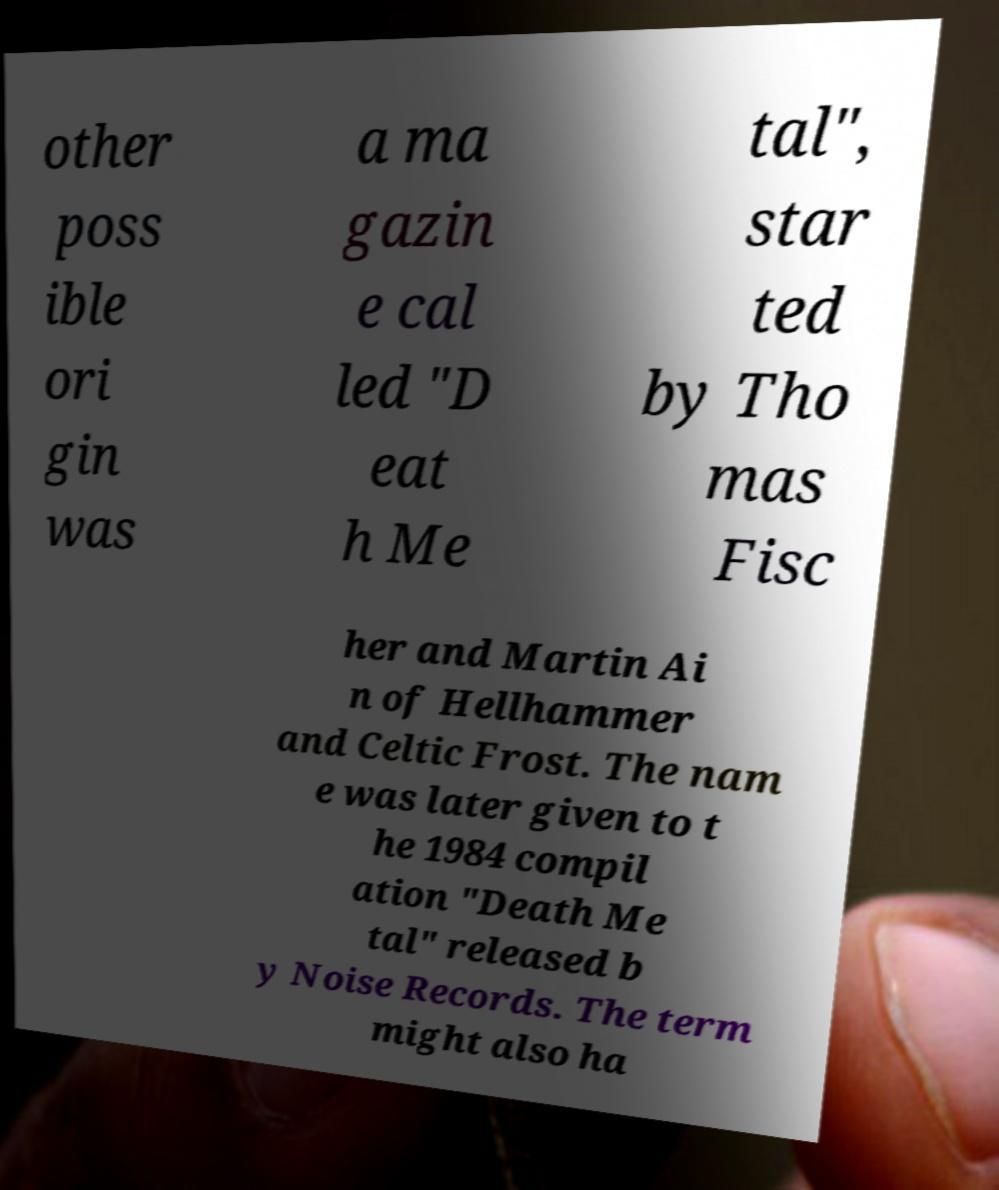Please read and relay the text visible in this image. What does it say? other poss ible ori gin was a ma gazin e cal led "D eat h Me tal", star ted by Tho mas Fisc her and Martin Ai n of Hellhammer and Celtic Frost. The nam e was later given to t he 1984 compil ation "Death Me tal" released b y Noise Records. The term might also ha 